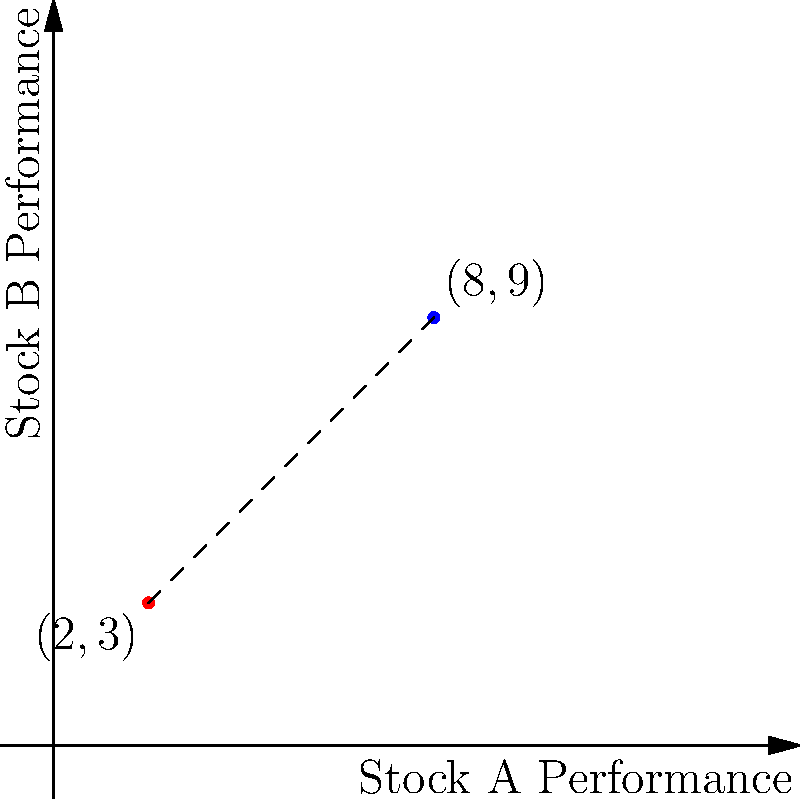As a seasoned investment advisor, you're analyzing the performance of two stocks over a specific period. Stock A's performance is represented by the point (2,3), while Stock B's performance is represented by (8,9) on a coordinate plane. Calculate the Euclidean distance between these two performance points to determine the relative volatility between the stocks. Round your answer to two decimal places. To calculate the Euclidean distance between two points on a coordinate plane, we use the distance formula:

$$d = \sqrt{(x_2 - x_1)^2 + (y_2 - y_1)^2}$$

Where $(x_1, y_1)$ represents the coordinates of the first point and $(x_2, y_2)$ represents the coordinates of the second point.

Given:
Point 1 (Stock A): $(2, 3)$
Point 2 (Stock B): $(8, 9)$

Step 1: Identify the coordinates
$x_1 = 2$, $y_1 = 3$
$x_2 = 8$, $y_2 = 9$

Step 2: Substitute these values into the distance formula
$$d = \sqrt{(8 - 2)^2 + (9 - 3)^2}$$

Step 3: Simplify the expressions inside the parentheses
$$d = \sqrt{6^2 + 6^2}$$

Step 4: Calculate the squares
$$d = \sqrt{36 + 36}$$

Step 5: Add the values under the square root
$$d = \sqrt{72}$$

Step 6: Simplify the square root
$$d = 6\sqrt{2}$$

Step 7: Calculate the approximate value and round to two decimal places
$$d \approx 8.49$$

This distance represents the relative volatility between the two stocks' performances.
Answer: 8.49 